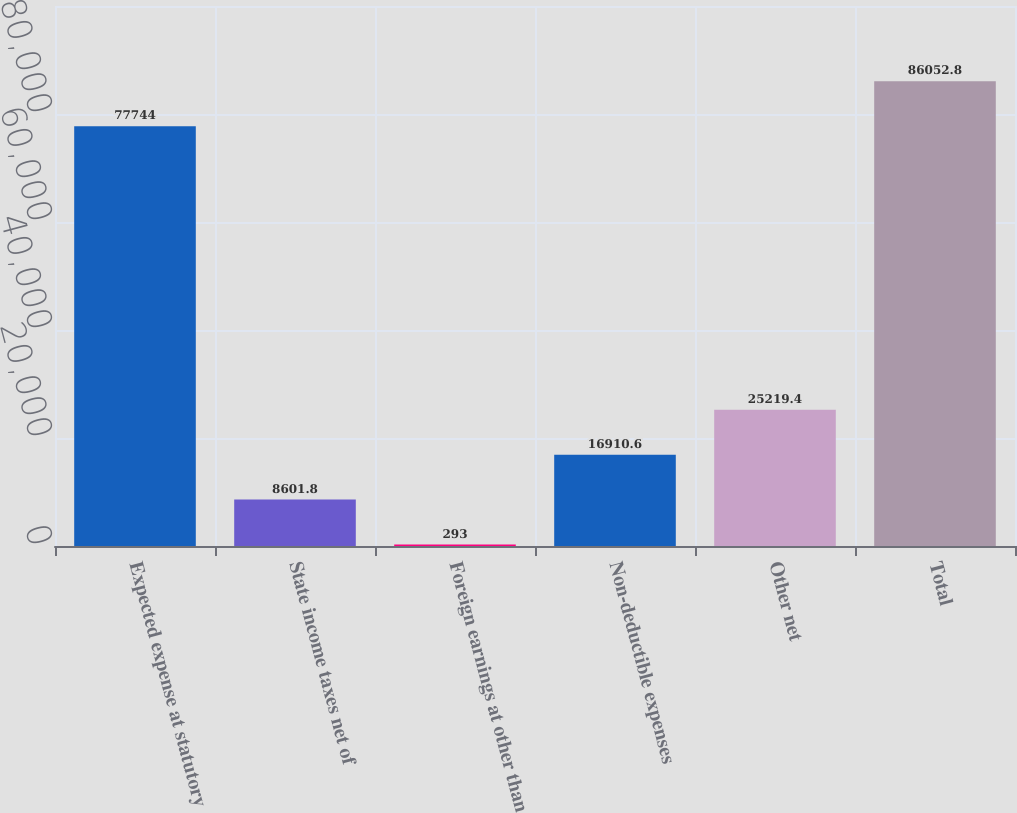Convert chart to OTSL. <chart><loc_0><loc_0><loc_500><loc_500><bar_chart><fcel>Expected expense at statutory<fcel>State income taxes net of<fcel>Foreign earnings at other than<fcel>Non-deductible expenses<fcel>Other net<fcel>Total<nl><fcel>77744<fcel>8601.8<fcel>293<fcel>16910.6<fcel>25219.4<fcel>86052.8<nl></chart> 